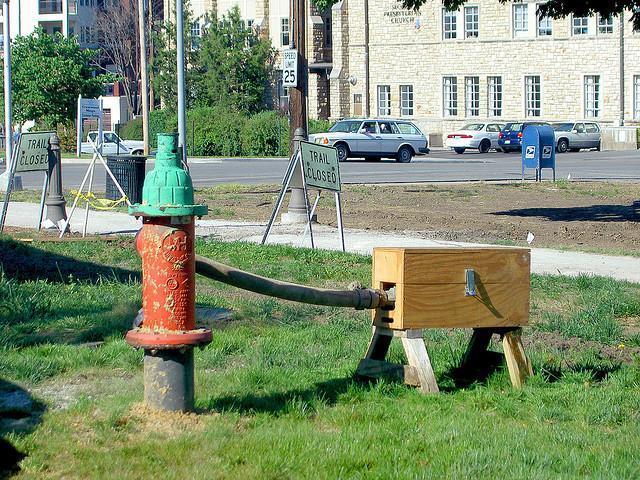How many cars are there?
Give a very brief answer. 5. How many fire hydrants are in the photo?
Give a very brief answer. 1. How many people can be seen?
Give a very brief answer. 0. 